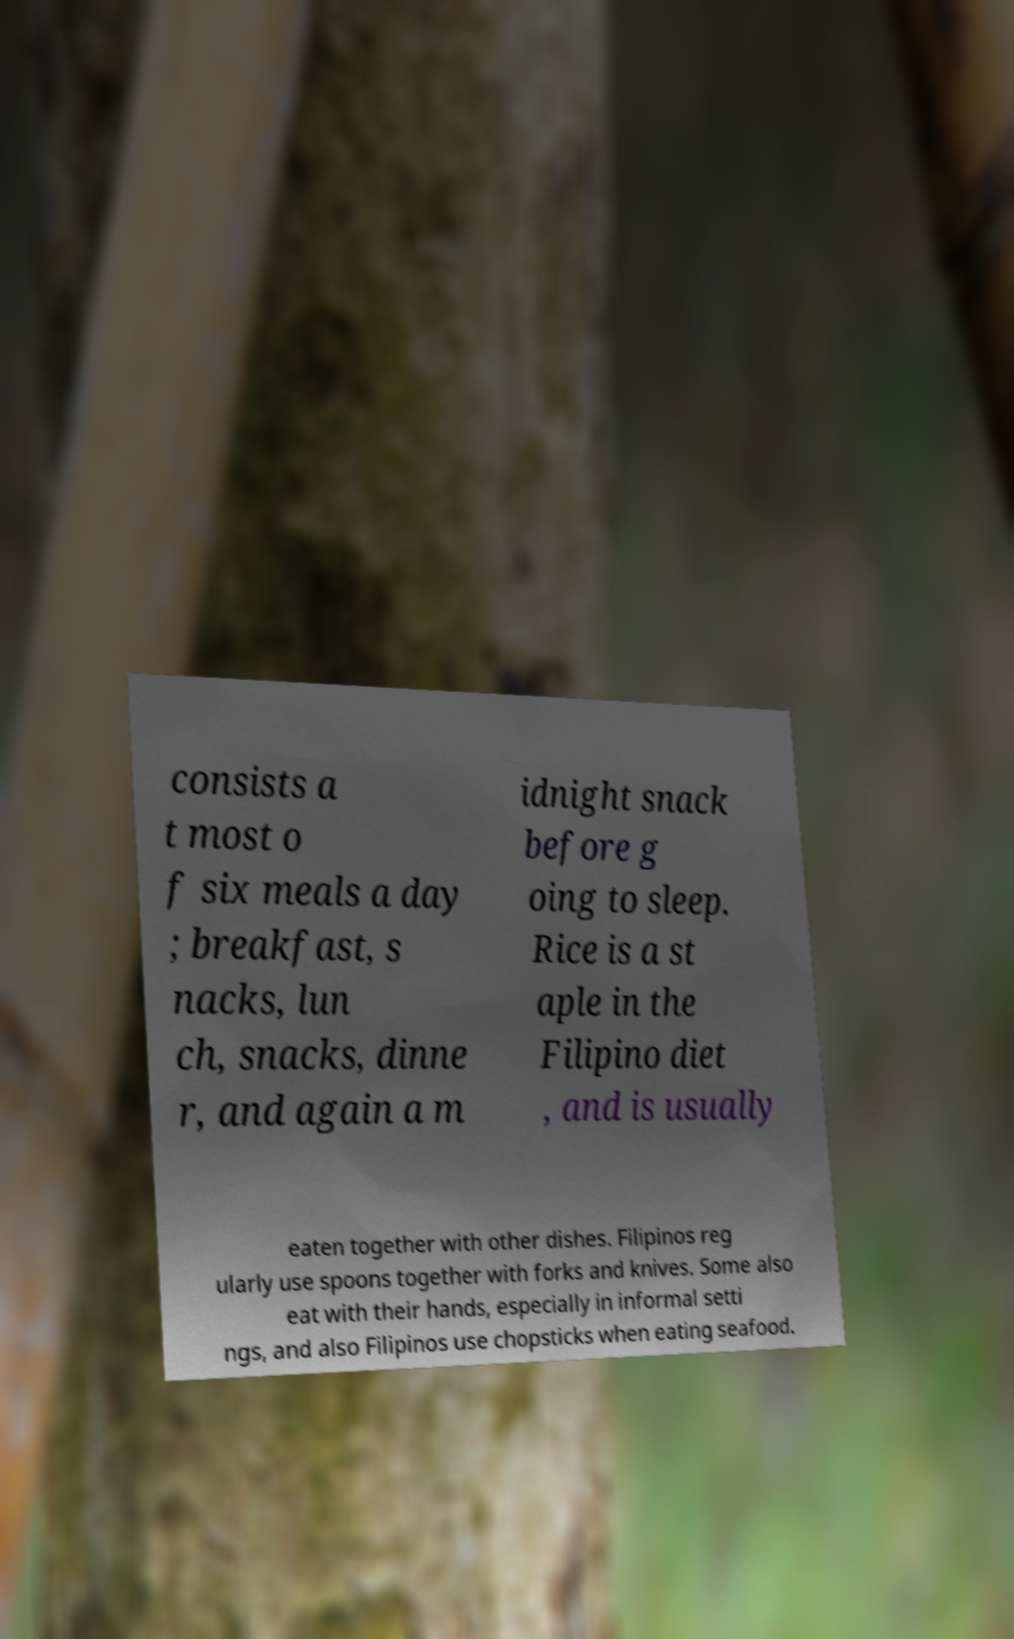Please identify and transcribe the text found in this image. consists a t most o f six meals a day ; breakfast, s nacks, lun ch, snacks, dinne r, and again a m idnight snack before g oing to sleep. Rice is a st aple in the Filipino diet , and is usually eaten together with other dishes. Filipinos reg ularly use spoons together with forks and knives. Some also eat with their hands, especially in informal setti ngs, and also Filipinos use chopsticks when eating seafood. 